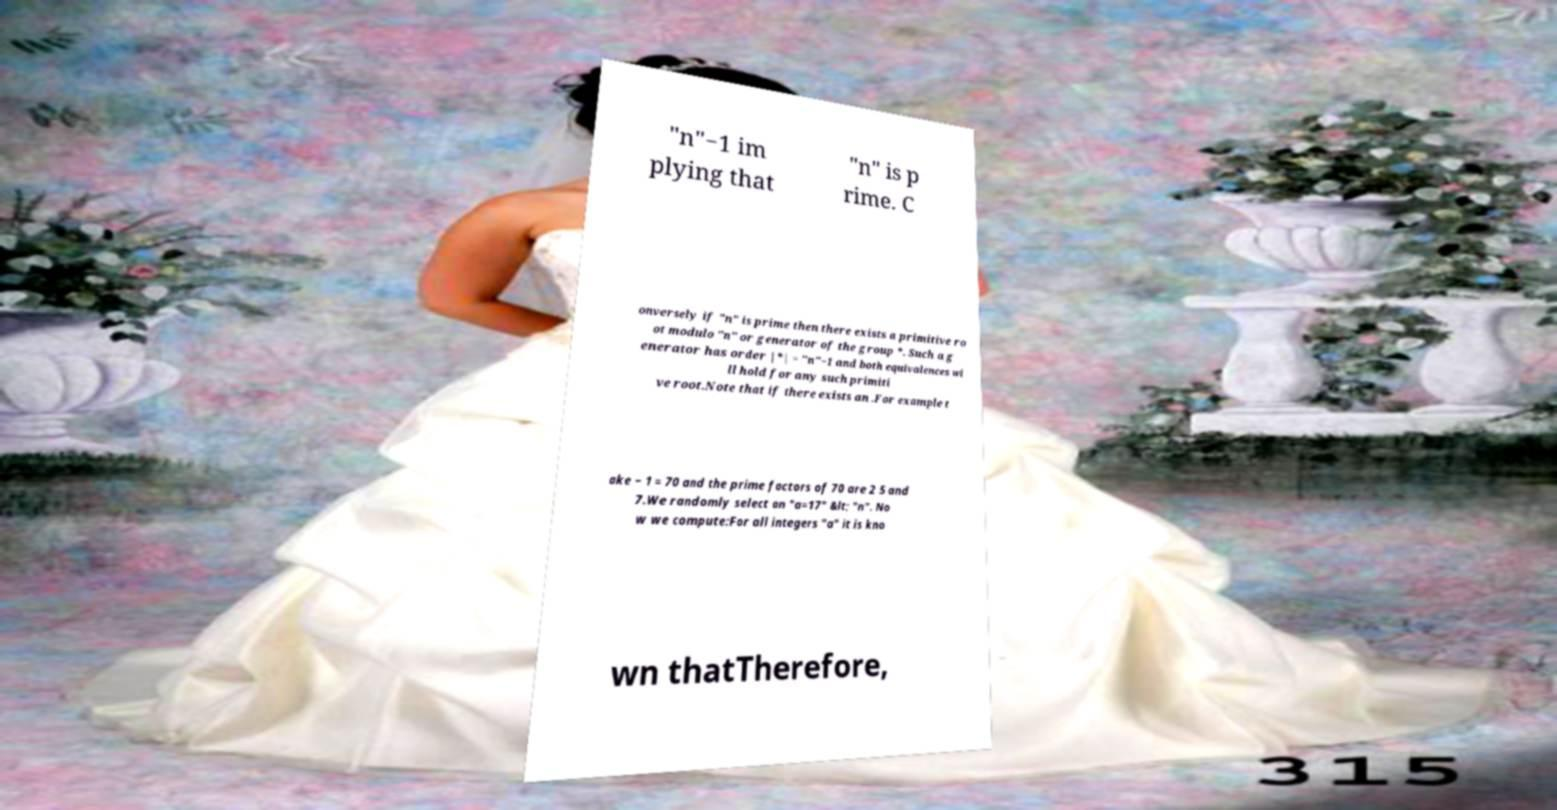Please read and relay the text visible in this image. What does it say? "n"−1 im plying that "n" is p rime. C onversely if "n" is prime then there exists a primitive ro ot modulo "n" or generator of the group *. Such a g enerator has order |*| = "n"−1 and both equivalences wi ll hold for any such primiti ve root.Note that if there exists an .For example t ake − 1 = 70 and the prime factors of 70 are 2 5 and 7.We randomly select an "a=17" &lt; "n". No w we compute:For all integers "a" it is kno wn thatTherefore, 